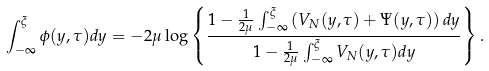<formula> <loc_0><loc_0><loc_500><loc_500>\int _ { - \infty } ^ { \xi } \phi ( y , \tau ) d y = - 2 \mu \log \left \{ \frac { 1 - \frac { 1 } { 2 \mu } \int _ { - \infty } ^ { \xi } \left ( V _ { N } ( y , \tau ) + \Psi ( y , \tau ) \right ) d y } { 1 - \frac { 1 } { 2 \mu } \int _ { - \infty } ^ { \xi } V _ { N } ( y , \tau ) d y } \right \} .</formula> 